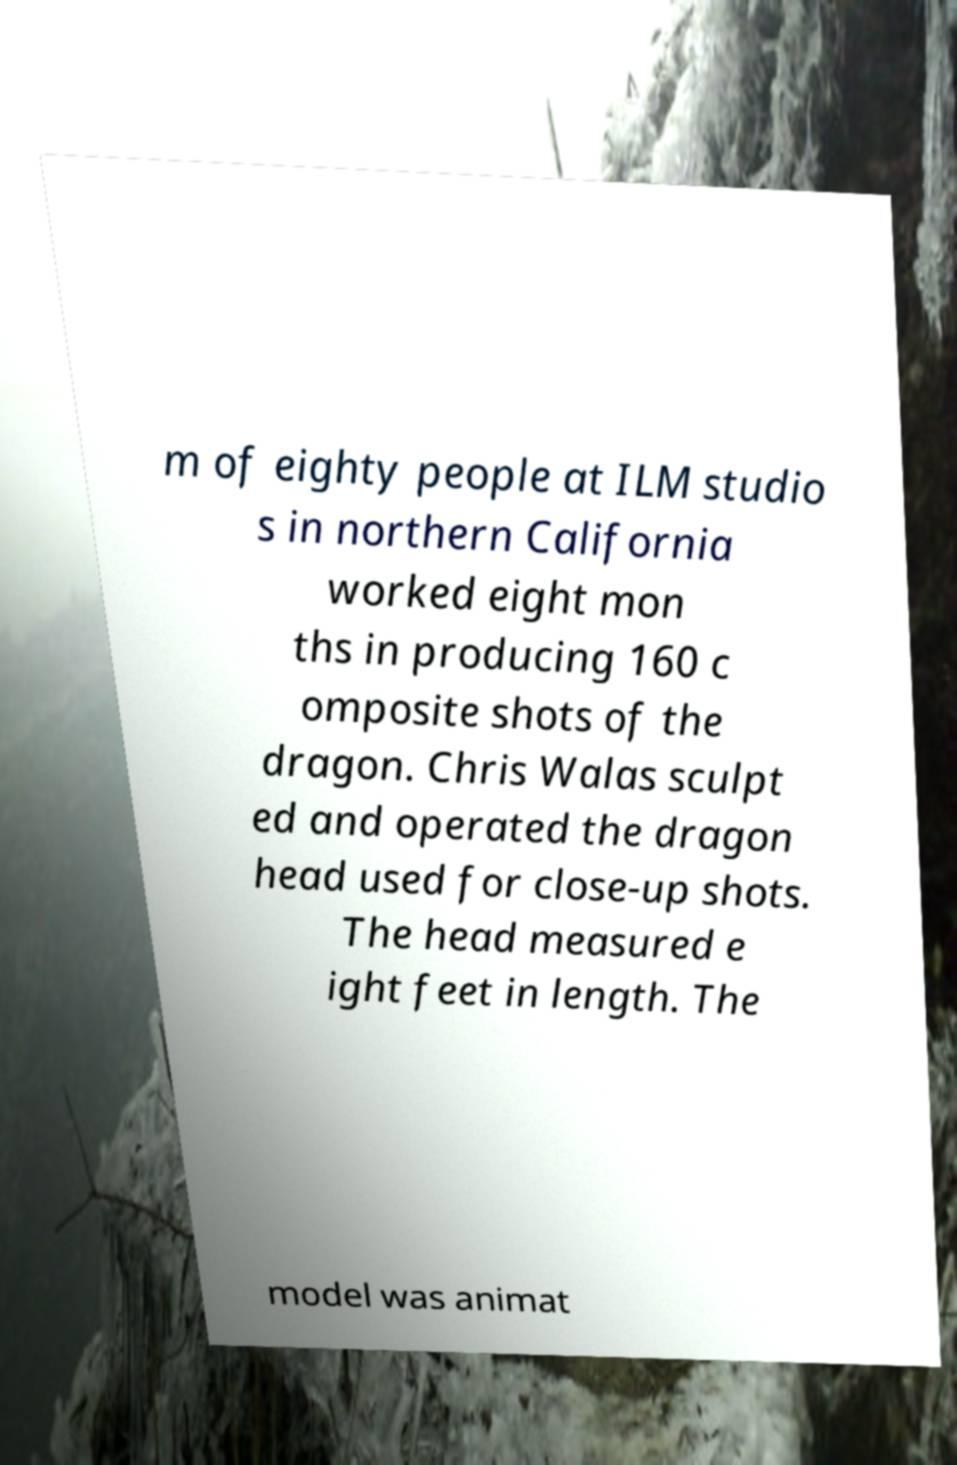Please identify and transcribe the text found in this image. m of eighty people at ILM studio s in northern California worked eight mon ths in producing 160 c omposite shots of the dragon. Chris Walas sculpt ed and operated the dragon head used for close-up shots. The head measured e ight feet in length. The model was animat 